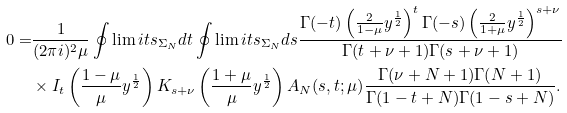Convert formula to latex. <formula><loc_0><loc_0><loc_500><loc_500>0 = & \frac { 1 } { ( 2 \pi i ) ^ { 2 } \mu } \oint \lim i t s _ { \Sigma _ { N } } d t \oint \lim i t s _ { \Sigma _ { N } } d s \frac { \Gamma ( - t ) \left ( \frac { 2 } { 1 - \mu } y ^ { \frac { 1 } { 2 } } \right ) ^ { t } \Gamma ( - s ) \left ( \frac { 2 } { 1 + \mu } y ^ { \frac { 1 } { 2 } } \right ) ^ { s + \nu } } { \Gamma ( t + \nu + 1 ) \Gamma ( s + \nu + 1 ) } \\ & \times I _ { t } \left ( \frac { 1 - \mu } { \mu } y ^ { \frac { 1 } { 2 } } \right ) K _ { s + \nu } \left ( \frac { 1 + \mu } { \mu } y ^ { \frac { 1 } { 2 } } \right ) A _ { N } ( s , t ; \mu ) \frac { \Gamma ( \nu + N + 1 ) \Gamma ( N + 1 ) } { \Gamma ( 1 - t + N ) \Gamma ( 1 - s + N ) } .</formula> 